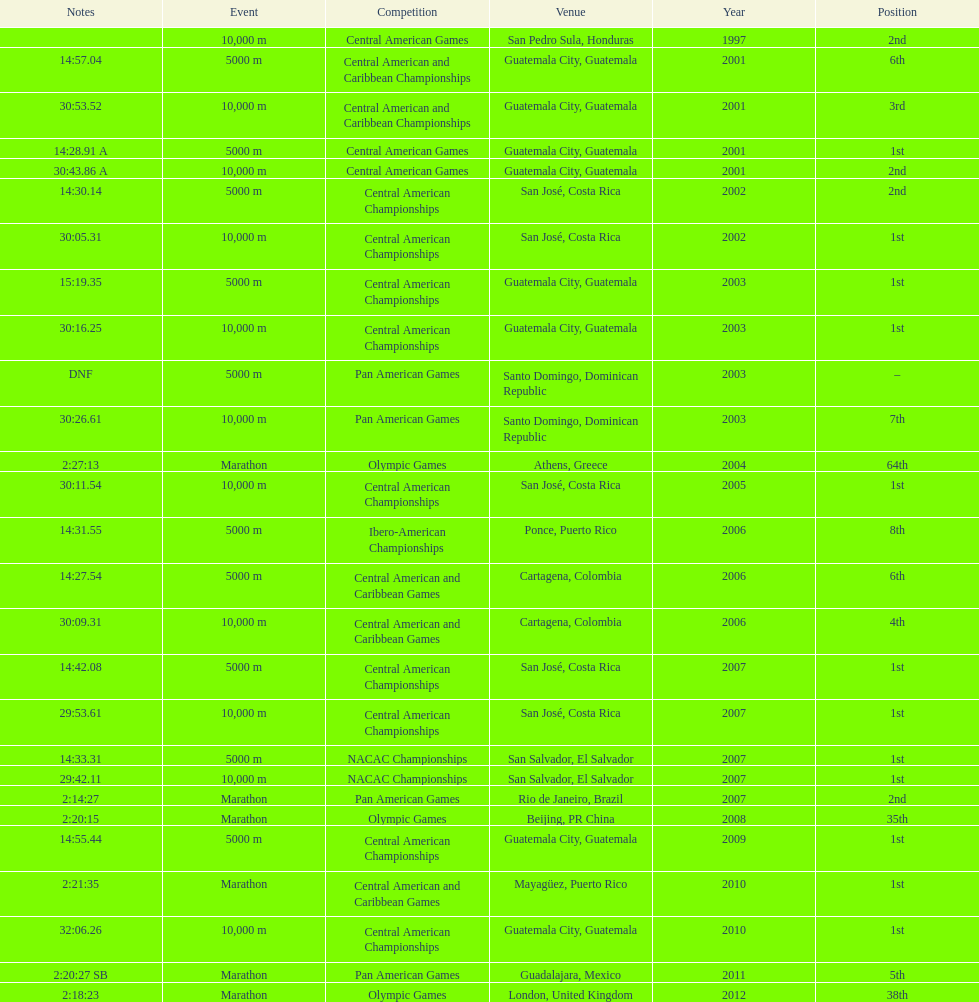What was the last competition in which a position of "2nd" was achieved? Pan American Games. 